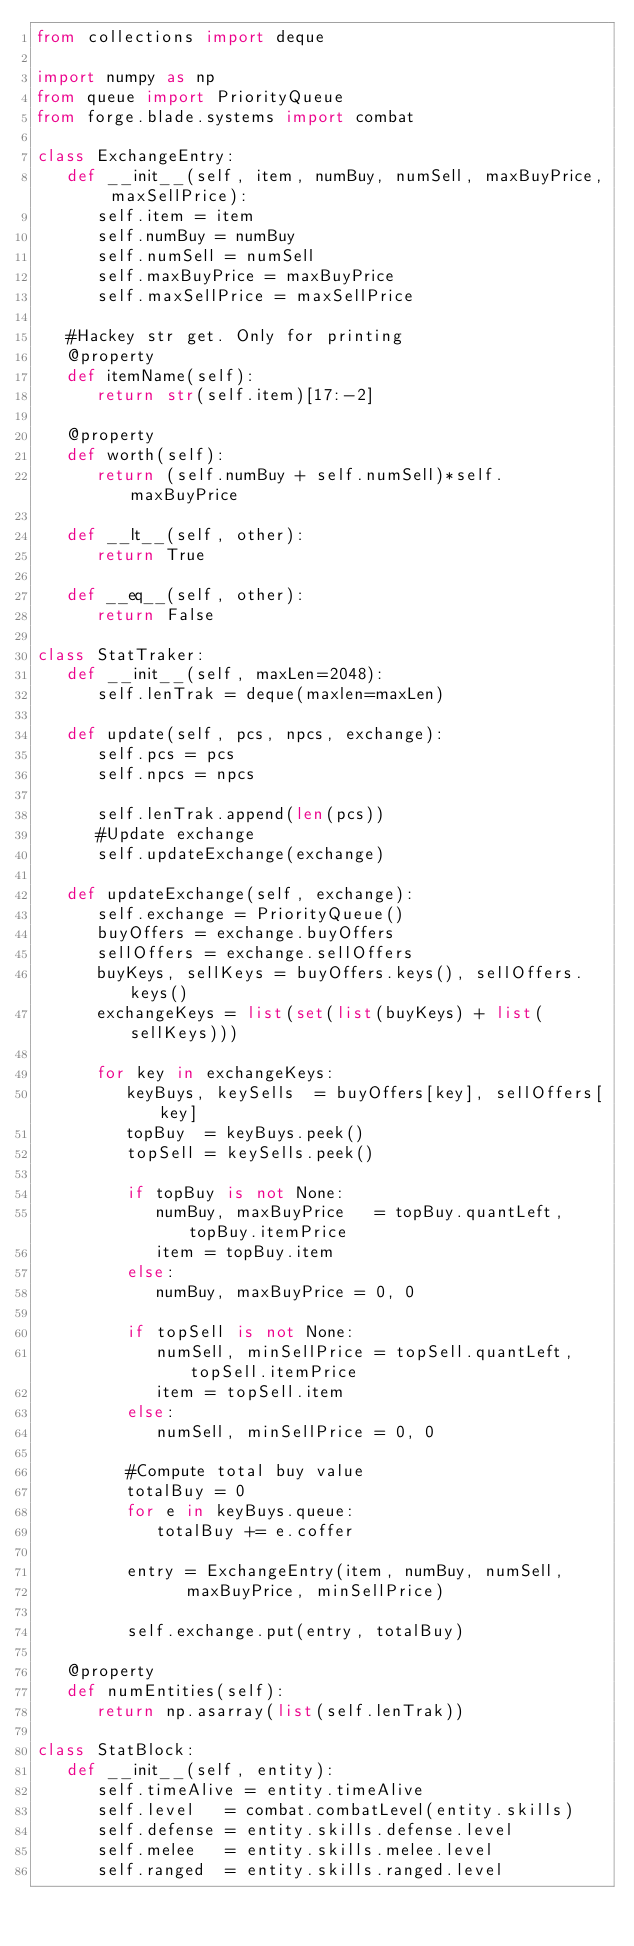<code> <loc_0><loc_0><loc_500><loc_500><_Python_>from collections import deque

import numpy as np
from queue import PriorityQueue
from forge.blade.systems import combat

class ExchangeEntry:
   def __init__(self, item, numBuy, numSell, maxBuyPrice, maxSellPrice):
      self.item = item
      self.numBuy = numBuy
      self.numSell = numSell
      self.maxBuyPrice = maxBuyPrice
      self.maxSellPrice = maxSellPrice

   #Hackey str get. Only for printing
   @property
   def itemName(self):
      return str(self.item)[17:-2]

   @property
   def worth(self):
      return (self.numBuy + self.numSell)*self.maxBuyPrice

   def __lt__(self, other):
      return True

   def __eq__(self, other):
      return False

class StatTraker:
   def __init__(self, maxLen=2048):
      self.lenTrak = deque(maxlen=maxLen)

   def update(self, pcs, npcs, exchange):
      self.pcs = pcs
      self.npcs = npcs
      
      self.lenTrak.append(len(pcs))
      #Update exchange
      self.updateExchange(exchange)
   
   def updateExchange(self, exchange):
      self.exchange = PriorityQueue()
      buyOffers = exchange.buyOffers
      sellOffers = exchange.sellOffers
      buyKeys, sellKeys = buyOffers.keys(), sellOffers.keys()
      exchangeKeys = list(set(list(buyKeys) + list(sellKeys)))

      for key in exchangeKeys:
         keyBuys, keySells  = buyOffers[key], sellOffers[key]
         topBuy  = keyBuys.peek()
         topSell = keySells.peek()

         if topBuy is not None:
            numBuy, maxBuyPrice   = topBuy.quantLeft, topBuy.itemPrice
            item = topBuy.item
         else:
            numBuy, maxBuyPrice = 0, 0

         if topSell is not None:
            numSell, minSellPrice = topSell.quantLeft, topSell.itemPrice
            item = topSell.item
         else:
            numSell, minSellPrice = 0, 0

         #Compute total buy value
         totalBuy = 0
         for e in keyBuys.queue:
            totalBuy += e.coffer

         entry = ExchangeEntry(item, numBuy, numSell, 
               maxBuyPrice, minSellPrice)

         self.exchange.put(entry, totalBuy)
 
   @property
   def numEntities(self):
      return np.asarray(list(self.lenTrak))

class StatBlock:
   def __init__(self, entity):
      self.timeAlive = entity.timeAlive
      self.level   = combat.combatLevel(entity.skills)
      self.defense = entity.skills.defense.level
      self.melee   = entity.skills.melee.level
      self.ranged  = entity.skills.ranged.level
      
   
</code> 